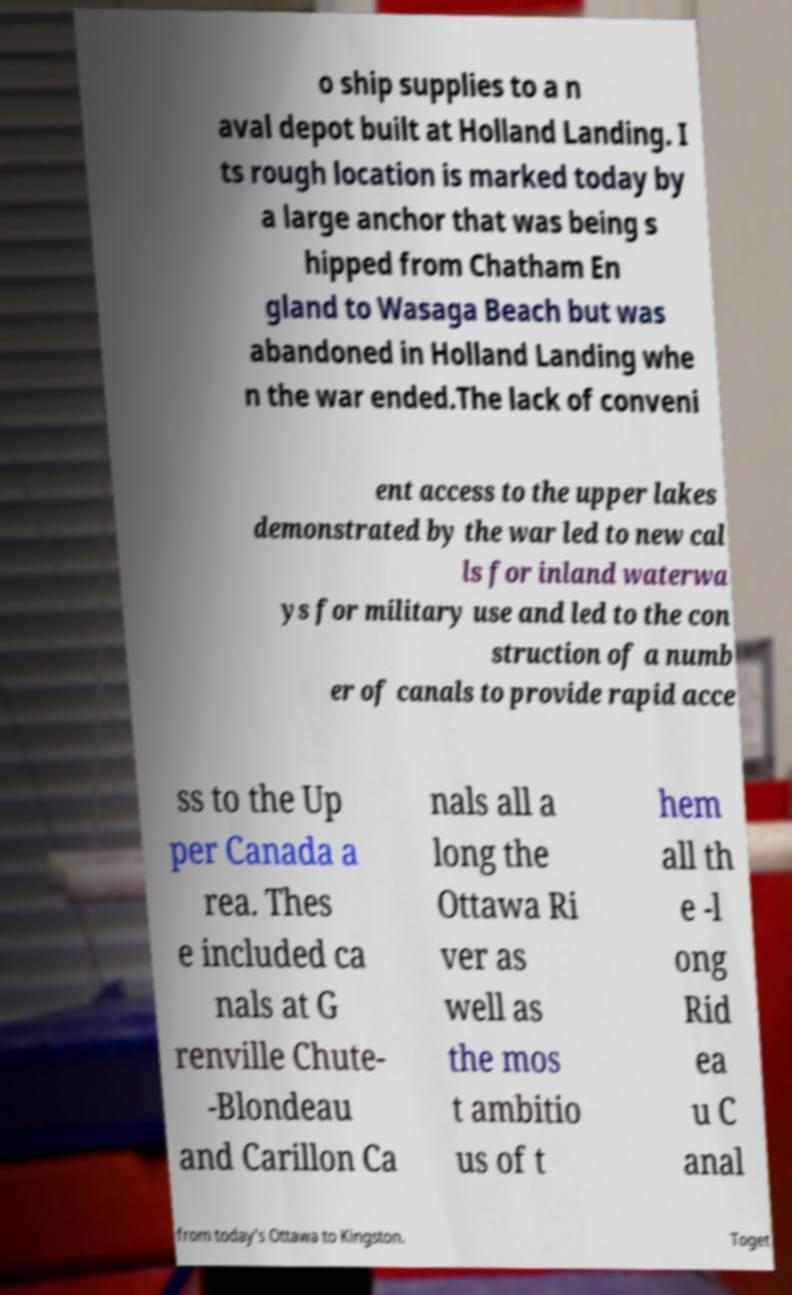Can you accurately transcribe the text from the provided image for me? o ship supplies to a n aval depot built at Holland Landing. I ts rough location is marked today by a large anchor that was being s hipped from Chatham En gland to Wasaga Beach but was abandoned in Holland Landing whe n the war ended.The lack of conveni ent access to the upper lakes demonstrated by the war led to new cal ls for inland waterwa ys for military use and led to the con struction of a numb er of canals to provide rapid acce ss to the Up per Canada a rea. Thes e included ca nals at G renville Chute- -Blondeau and Carillon Ca nals all a long the Ottawa Ri ver as well as the mos t ambitio us of t hem all th e -l ong Rid ea u C anal from today's Ottawa to Kingston. Toget 